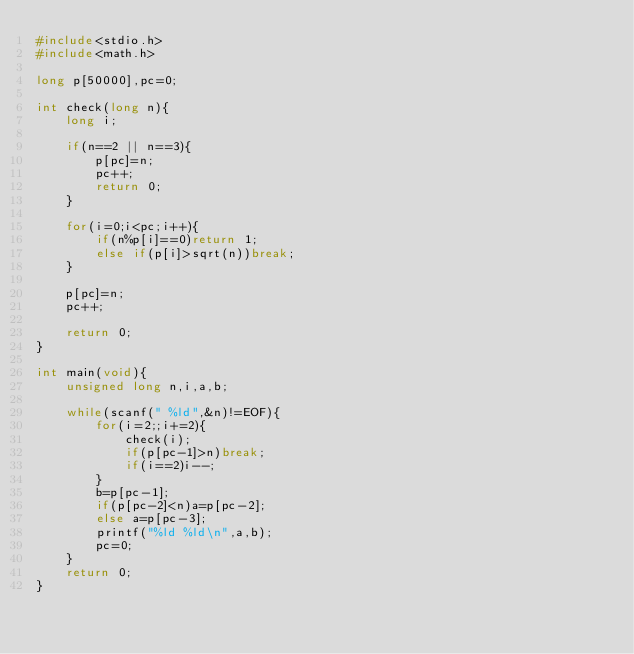<code> <loc_0><loc_0><loc_500><loc_500><_C_>#include<stdio.h>
#include<math.h>

long p[50000],pc=0;

int check(long n){
	long i;
	
	if(n==2 || n==3){
		p[pc]=n;
		pc++;
		return 0;
	}
	
	for(i=0;i<pc;i++){
		if(n%p[i]==0)return 1;
		else if(p[i]>sqrt(n))break;
	}
	
	p[pc]=n;
	pc++;
	
	return 0;
}

int main(void){
	unsigned long n,i,a,b;
	
	while(scanf(" %ld",&n)!=EOF){
		for(i=2;;i+=2){
			check(i);
			if(p[pc-1]>n)break;
			if(i==2)i--;
		}
		b=p[pc-1];
		if(p[pc-2]<n)a=p[pc-2];
		else a=p[pc-3];
		printf("%ld %ld\n",a,b);
		pc=0;
	}
	return 0;
}</code> 